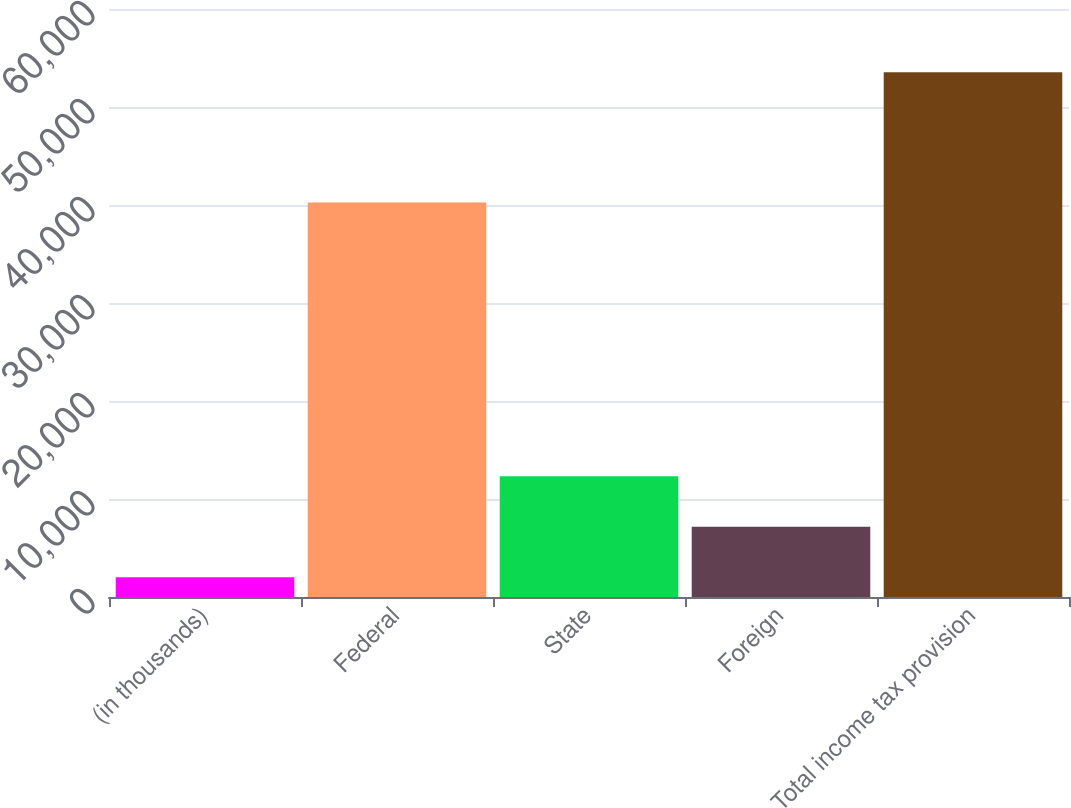Convert chart to OTSL. <chart><loc_0><loc_0><loc_500><loc_500><bar_chart><fcel>(in thousands)<fcel>Federal<fcel>State<fcel>Foreign<fcel>Total income tax provision<nl><fcel>2010<fcel>40250<fcel>12316.6<fcel>7163.3<fcel>53543<nl></chart> 